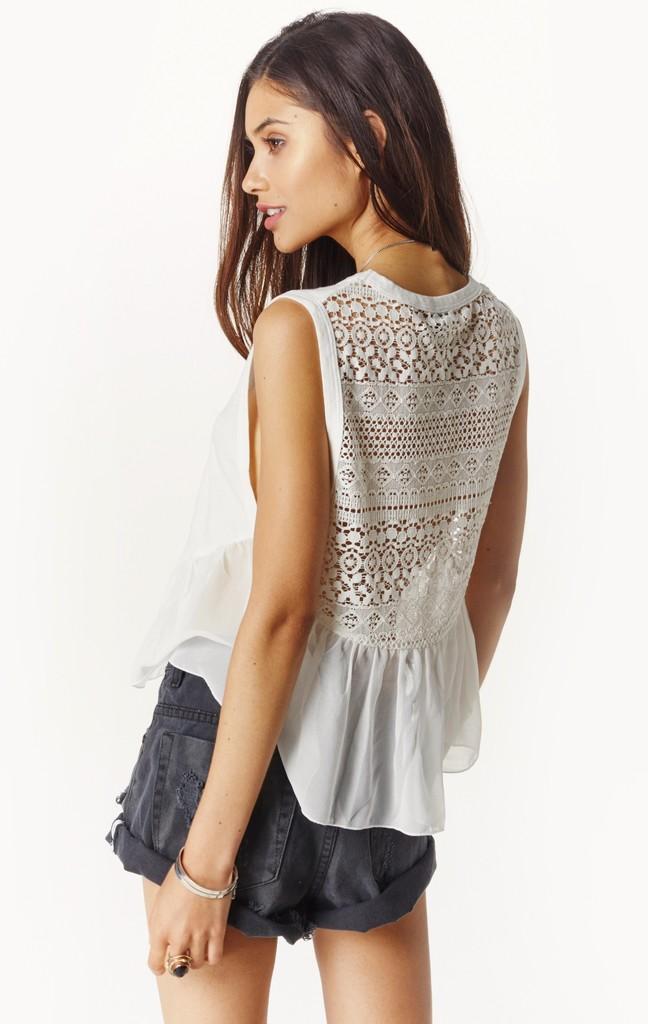Describe this image in one or two sentences. In this image there is a woman standing ,and there is white background. 